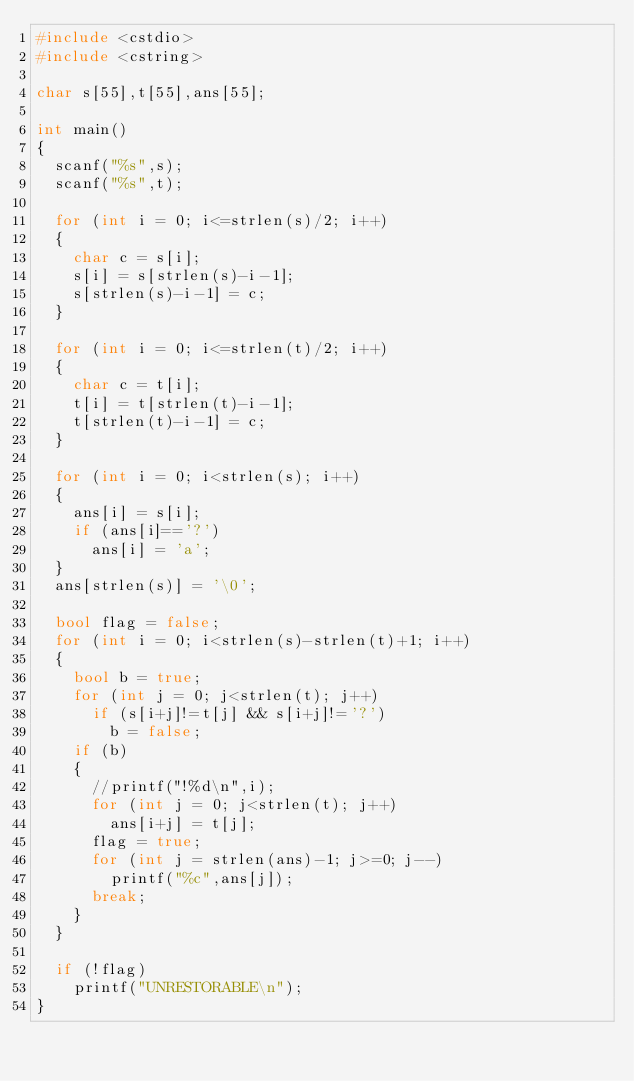Convert code to text. <code><loc_0><loc_0><loc_500><loc_500><_C++_>#include <cstdio>
#include <cstring>

char s[55],t[55],ans[55];

int main()
{
	scanf("%s",s);
	scanf("%s",t);

	for (int i = 0; i<=strlen(s)/2; i++)
	{
		char c = s[i];
		s[i] = s[strlen(s)-i-1];
		s[strlen(s)-i-1] = c;
	}

	for (int i = 0; i<=strlen(t)/2; i++)
	{
		char c = t[i];
		t[i] = t[strlen(t)-i-1];
		t[strlen(t)-i-1] = c;
	}

	for (int i = 0; i<strlen(s); i++)
	{
		ans[i] = s[i];
		if (ans[i]=='?')
			ans[i] = 'a';
	}
	ans[strlen(s)] = '\0';

	bool flag = false;
	for (int i = 0; i<strlen(s)-strlen(t)+1; i++)
	{
		bool b = true;
		for (int j = 0; j<strlen(t); j++)
			if (s[i+j]!=t[j] && s[i+j]!='?')
				b = false;
		if (b)
		{
			//printf("!%d\n",i);
			for (int j = 0; j<strlen(t); j++)
				ans[i+j] = t[j];
			flag = true;
			for (int j = strlen(ans)-1; j>=0; j--)
				printf("%c",ans[j]);
			break;
		}
	}	

	if (!flag)
		printf("UNRESTORABLE\n");
}</code> 